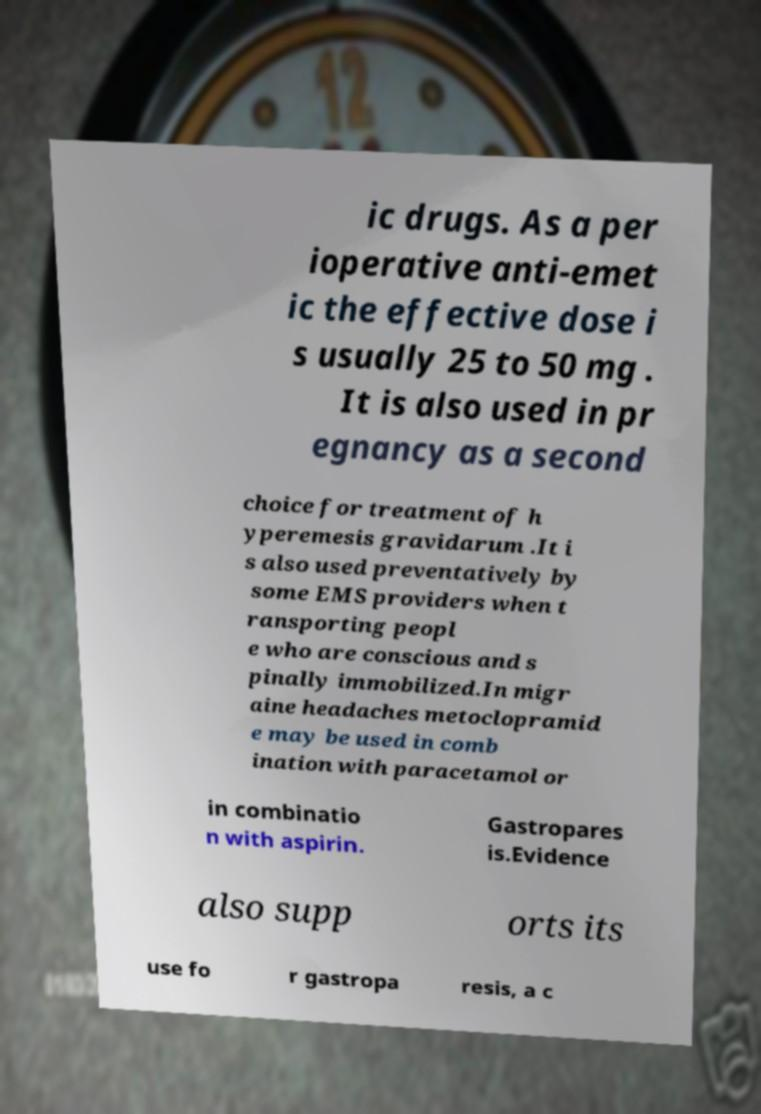There's text embedded in this image that I need extracted. Can you transcribe it verbatim? ic drugs. As a per ioperative anti-emet ic the effective dose i s usually 25 to 50 mg . It is also used in pr egnancy as a second choice for treatment of h yperemesis gravidarum .It i s also used preventatively by some EMS providers when t ransporting peopl e who are conscious and s pinally immobilized.In migr aine headaches metoclopramid e may be used in comb ination with paracetamol or in combinatio n with aspirin. Gastropares is.Evidence also supp orts its use fo r gastropa resis, a c 